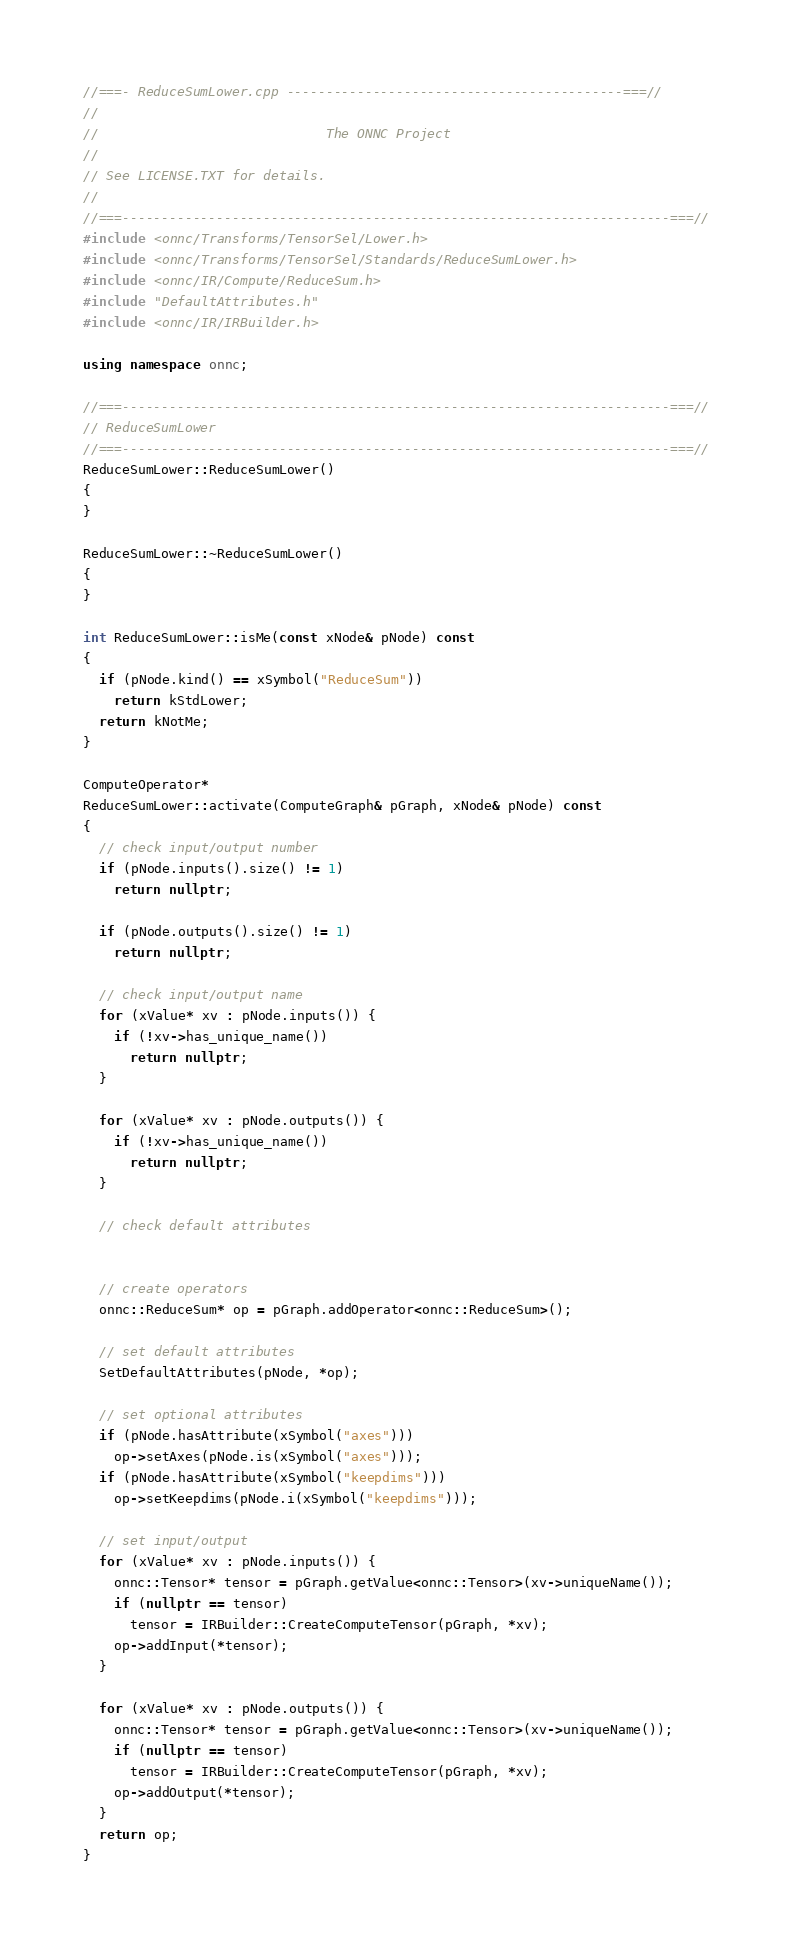<code> <loc_0><loc_0><loc_500><loc_500><_C++_>//===- ReduceSumLower.cpp -------------------------------------------===//
//
//                             The ONNC Project
//
// See LICENSE.TXT for details.
//
//===----------------------------------------------------------------------===//
#include <onnc/Transforms/TensorSel/Lower.h>
#include <onnc/Transforms/TensorSel/Standards/ReduceSumLower.h>
#include <onnc/IR/Compute/ReduceSum.h>
#include "DefaultAttributes.h"
#include <onnc/IR/IRBuilder.h>

using namespace onnc;

//===----------------------------------------------------------------------===//
// ReduceSumLower
//===----------------------------------------------------------------------===//
ReduceSumLower::ReduceSumLower()
{
}

ReduceSumLower::~ReduceSumLower()
{
}

int ReduceSumLower::isMe(const xNode& pNode) const
{
  if (pNode.kind() == xSymbol("ReduceSum"))
    return kStdLower;
  return kNotMe;
}

ComputeOperator*
ReduceSumLower::activate(ComputeGraph& pGraph, xNode& pNode) const
{
  // check input/output number
  if (pNode.inputs().size() != 1)
    return nullptr;

  if (pNode.outputs().size() != 1)
    return nullptr;

  // check input/output name
  for (xValue* xv : pNode.inputs()) {
    if (!xv->has_unique_name())
      return nullptr;
  }

  for (xValue* xv : pNode.outputs()) {
    if (!xv->has_unique_name())
      return nullptr;
  }

  // check default attributes
  

  // create operators
  onnc::ReduceSum* op = pGraph.addOperator<onnc::ReduceSum>();

  // set default attributes
  SetDefaultAttributes(pNode, *op);

  // set optional attributes
  if (pNode.hasAttribute(xSymbol("axes")))
    op->setAxes(pNode.is(xSymbol("axes")));
  if (pNode.hasAttribute(xSymbol("keepdims")))
    op->setKeepdims(pNode.i(xSymbol("keepdims")));

  // set input/output
  for (xValue* xv : pNode.inputs()) {
    onnc::Tensor* tensor = pGraph.getValue<onnc::Tensor>(xv->uniqueName());
    if (nullptr == tensor)
      tensor = IRBuilder::CreateComputeTensor(pGraph, *xv);
    op->addInput(*tensor);
  }

  for (xValue* xv : pNode.outputs()) {
    onnc::Tensor* tensor = pGraph.getValue<onnc::Tensor>(xv->uniqueName());
    if (nullptr == tensor)
      tensor = IRBuilder::CreateComputeTensor(pGraph, *xv);
    op->addOutput(*tensor);
  }
  return op;
}
</code> 